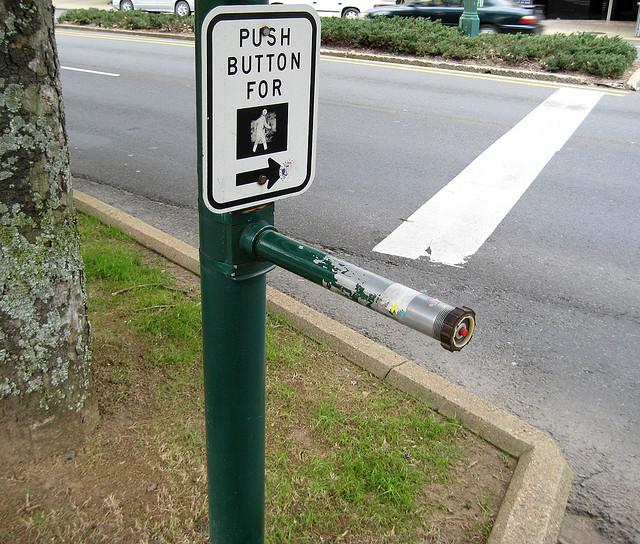What's behind the green pole?
Give a very brief answer. Tree. Can people safely cross the road here?
Concise answer only. Yes. What does the sign say?
Keep it brief. Push button for. Is the pavement made of bricks?
Short answer required. No. 